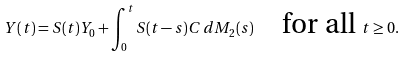Convert formula to latex. <formula><loc_0><loc_0><loc_500><loc_500>Y ( t ) = S ( t ) Y _ { 0 } + \int _ { 0 } ^ { t } S ( t - s ) C \, d M _ { 2 } ( s ) \quad \text {for all } t \geq 0 .</formula> 